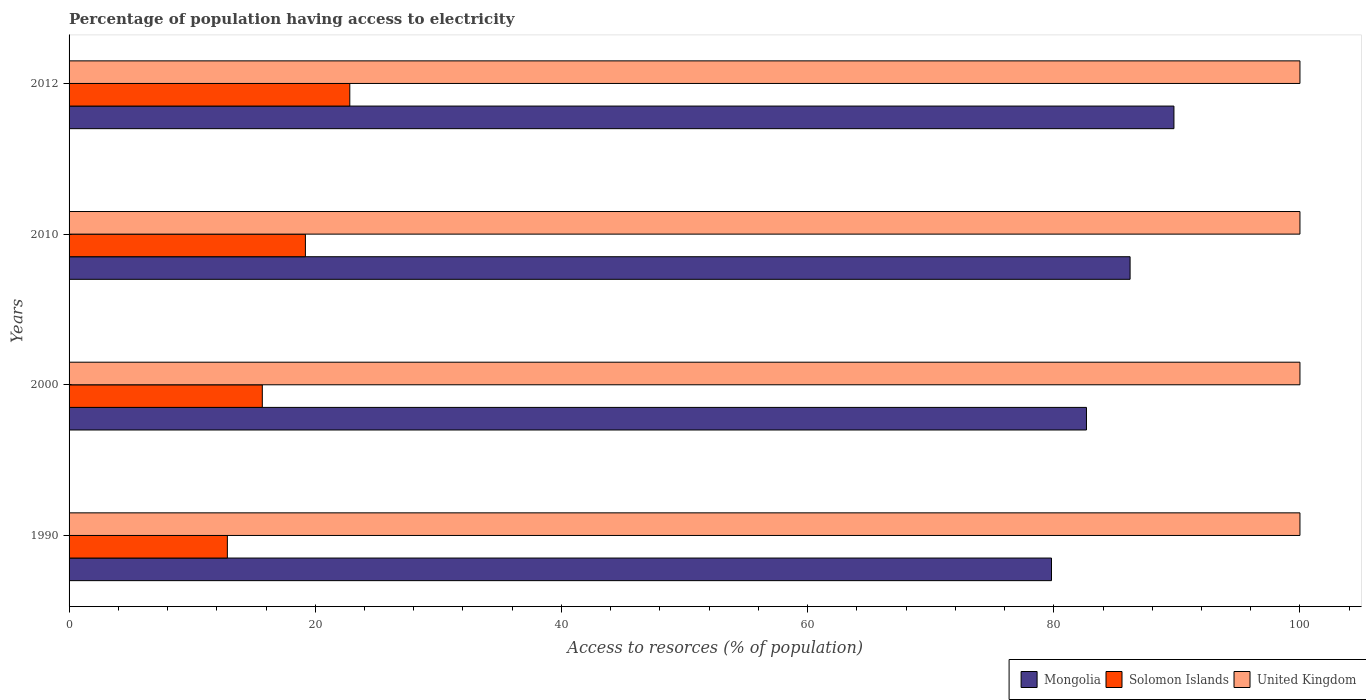How many different coloured bars are there?
Offer a terse response. 3. How many groups of bars are there?
Give a very brief answer. 4. Are the number of bars per tick equal to the number of legend labels?
Keep it short and to the point. Yes. Are the number of bars on each tick of the Y-axis equal?
Your answer should be very brief. Yes. How many bars are there on the 1st tick from the top?
Offer a terse response. 3. How many bars are there on the 1st tick from the bottom?
Give a very brief answer. 3. What is the percentage of population having access to electricity in Mongolia in 2010?
Your answer should be very brief. 86.2. Across all years, what is the maximum percentage of population having access to electricity in Solomon Islands?
Give a very brief answer. 22.81. Across all years, what is the minimum percentage of population having access to electricity in Mongolia?
Your answer should be very brief. 79.82. In which year was the percentage of population having access to electricity in Mongolia maximum?
Make the answer very short. 2012. In which year was the percentage of population having access to electricity in Mongolia minimum?
Your response must be concise. 1990. What is the total percentage of population having access to electricity in Solomon Islands in the graph?
Offer a terse response. 70.57. What is the difference between the percentage of population having access to electricity in Solomon Islands in 1990 and that in 2012?
Your response must be concise. -9.95. What is the difference between the percentage of population having access to electricity in Solomon Islands in 2000 and the percentage of population having access to electricity in Mongolia in 2012?
Your answer should be very brief. -74.06. What is the average percentage of population having access to electricity in Mongolia per year?
Your response must be concise. 84.61. In the year 2012, what is the difference between the percentage of population having access to electricity in Solomon Islands and percentage of population having access to electricity in Mongolia?
Make the answer very short. -66.96. What is the ratio of the percentage of population having access to electricity in United Kingdom in 1990 to that in 2012?
Offer a very short reply. 1. What is the difference between the highest and the lowest percentage of population having access to electricity in Solomon Islands?
Offer a terse response. 9.95. In how many years, is the percentage of population having access to electricity in Mongolia greater than the average percentage of population having access to electricity in Mongolia taken over all years?
Offer a terse response. 2. Is the sum of the percentage of population having access to electricity in Mongolia in 1990 and 2012 greater than the maximum percentage of population having access to electricity in United Kingdom across all years?
Your answer should be very brief. Yes. What does the 1st bar from the bottom in 1990 represents?
Offer a terse response. Mongolia. Is it the case that in every year, the sum of the percentage of population having access to electricity in Solomon Islands and percentage of population having access to electricity in United Kingdom is greater than the percentage of population having access to electricity in Mongolia?
Make the answer very short. Yes. How many bars are there?
Your answer should be compact. 12. How many years are there in the graph?
Provide a short and direct response. 4. Does the graph contain any zero values?
Offer a terse response. No. Does the graph contain grids?
Provide a succinct answer. No. Where does the legend appear in the graph?
Provide a short and direct response. Bottom right. How many legend labels are there?
Your answer should be compact. 3. How are the legend labels stacked?
Your response must be concise. Horizontal. What is the title of the graph?
Offer a terse response. Percentage of population having access to electricity. Does "Sao Tome and Principe" appear as one of the legend labels in the graph?
Your answer should be compact. No. What is the label or title of the X-axis?
Provide a succinct answer. Access to resorces (% of population). What is the Access to resorces (% of population) of Mongolia in 1990?
Give a very brief answer. 79.82. What is the Access to resorces (% of population) in Solomon Islands in 1990?
Provide a succinct answer. 12.86. What is the Access to resorces (% of population) in United Kingdom in 1990?
Your response must be concise. 100. What is the Access to resorces (% of population) of Mongolia in 2000?
Offer a terse response. 82.66. What is the Access to resorces (% of population) in Mongolia in 2010?
Give a very brief answer. 86.2. What is the Access to resorces (% of population) of Solomon Islands in 2010?
Make the answer very short. 19.2. What is the Access to resorces (% of population) of United Kingdom in 2010?
Offer a very short reply. 100. What is the Access to resorces (% of population) of Mongolia in 2012?
Your answer should be compact. 89.76. What is the Access to resorces (% of population) of Solomon Islands in 2012?
Provide a short and direct response. 22.81. What is the Access to resorces (% of population) in United Kingdom in 2012?
Keep it short and to the point. 100. Across all years, what is the maximum Access to resorces (% of population) of Mongolia?
Give a very brief answer. 89.76. Across all years, what is the maximum Access to resorces (% of population) in Solomon Islands?
Your answer should be compact. 22.81. Across all years, what is the minimum Access to resorces (% of population) of Mongolia?
Your response must be concise. 79.82. Across all years, what is the minimum Access to resorces (% of population) of Solomon Islands?
Keep it short and to the point. 12.86. Across all years, what is the minimum Access to resorces (% of population) in United Kingdom?
Provide a succinct answer. 100. What is the total Access to resorces (% of population) of Mongolia in the graph?
Your response must be concise. 338.43. What is the total Access to resorces (% of population) of Solomon Islands in the graph?
Provide a short and direct response. 70.57. What is the difference between the Access to resorces (% of population) of Mongolia in 1990 and that in 2000?
Offer a terse response. -2.84. What is the difference between the Access to resorces (% of population) of Solomon Islands in 1990 and that in 2000?
Your answer should be very brief. -2.84. What is the difference between the Access to resorces (% of population) of Mongolia in 1990 and that in 2010?
Offer a very short reply. -6.38. What is the difference between the Access to resorces (% of population) of Solomon Islands in 1990 and that in 2010?
Give a very brief answer. -6.34. What is the difference between the Access to resorces (% of population) in United Kingdom in 1990 and that in 2010?
Provide a short and direct response. 0. What is the difference between the Access to resorces (% of population) of Mongolia in 1990 and that in 2012?
Offer a terse response. -9.95. What is the difference between the Access to resorces (% of population) of Solomon Islands in 1990 and that in 2012?
Provide a short and direct response. -9.95. What is the difference between the Access to resorces (% of population) in United Kingdom in 1990 and that in 2012?
Keep it short and to the point. 0. What is the difference between the Access to resorces (% of population) in Mongolia in 2000 and that in 2010?
Your answer should be compact. -3.54. What is the difference between the Access to resorces (% of population) of Mongolia in 2000 and that in 2012?
Provide a succinct answer. -7.11. What is the difference between the Access to resorces (% of population) of Solomon Islands in 2000 and that in 2012?
Make the answer very short. -7.11. What is the difference between the Access to resorces (% of population) in Mongolia in 2010 and that in 2012?
Give a very brief answer. -3.56. What is the difference between the Access to resorces (% of population) in Solomon Islands in 2010 and that in 2012?
Offer a very short reply. -3.61. What is the difference between the Access to resorces (% of population) of United Kingdom in 2010 and that in 2012?
Your response must be concise. 0. What is the difference between the Access to resorces (% of population) in Mongolia in 1990 and the Access to resorces (% of population) in Solomon Islands in 2000?
Keep it short and to the point. 64.12. What is the difference between the Access to resorces (% of population) of Mongolia in 1990 and the Access to resorces (% of population) of United Kingdom in 2000?
Make the answer very short. -20.18. What is the difference between the Access to resorces (% of population) in Solomon Islands in 1990 and the Access to resorces (% of population) in United Kingdom in 2000?
Your answer should be very brief. -87.14. What is the difference between the Access to resorces (% of population) of Mongolia in 1990 and the Access to resorces (% of population) of Solomon Islands in 2010?
Make the answer very short. 60.62. What is the difference between the Access to resorces (% of population) of Mongolia in 1990 and the Access to resorces (% of population) of United Kingdom in 2010?
Give a very brief answer. -20.18. What is the difference between the Access to resorces (% of population) of Solomon Islands in 1990 and the Access to resorces (% of population) of United Kingdom in 2010?
Provide a succinct answer. -87.14. What is the difference between the Access to resorces (% of population) of Mongolia in 1990 and the Access to resorces (% of population) of Solomon Islands in 2012?
Your answer should be very brief. 57.01. What is the difference between the Access to resorces (% of population) in Mongolia in 1990 and the Access to resorces (% of population) in United Kingdom in 2012?
Provide a short and direct response. -20.18. What is the difference between the Access to resorces (% of population) of Solomon Islands in 1990 and the Access to resorces (% of population) of United Kingdom in 2012?
Keep it short and to the point. -87.14. What is the difference between the Access to resorces (% of population) in Mongolia in 2000 and the Access to resorces (% of population) in Solomon Islands in 2010?
Your answer should be very brief. 63.46. What is the difference between the Access to resorces (% of population) in Mongolia in 2000 and the Access to resorces (% of population) in United Kingdom in 2010?
Offer a terse response. -17.34. What is the difference between the Access to resorces (% of population) of Solomon Islands in 2000 and the Access to resorces (% of population) of United Kingdom in 2010?
Your answer should be compact. -84.3. What is the difference between the Access to resorces (% of population) of Mongolia in 2000 and the Access to resorces (% of population) of Solomon Islands in 2012?
Make the answer very short. 59.85. What is the difference between the Access to resorces (% of population) in Mongolia in 2000 and the Access to resorces (% of population) in United Kingdom in 2012?
Keep it short and to the point. -17.34. What is the difference between the Access to resorces (% of population) of Solomon Islands in 2000 and the Access to resorces (% of population) of United Kingdom in 2012?
Your response must be concise. -84.3. What is the difference between the Access to resorces (% of population) of Mongolia in 2010 and the Access to resorces (% of population) of Solomon Islands in 2012?
Your answer should be compact. 63.39. What is the difference between the Access to resorces (% of population) of Mongolia in 2010 and the Access to resorces (% of population) of United Kingdom in 2012?
Provide a succinct answer. -13.8. What is the difference between the Access to resorces (% of population) of Solomon Islands in 2010 and the Access to resorces (% of population) of United Kingdom in 2012?
Your response must be concise. -80.8. What is the average Access to resorces (% of population) of Mongolia per year?
Provide a short and direct response. 84.61. What is the average Access to resorces (% of population) in Solomon Islands per year?
Make the answer very short. 17.64. In the year 1990, what is the difference between the Access to resorces (% of population) in Mongolia and Access to resorces (% of population) in Solomon Islands?
Your response must be concise. 66.96. In the year 1990, what is the difference between the Access to resorces (% of population) in Mongolia and Access to resorces (% of population) in United Kingdom?
Make the answer very short. -20.18. In the year 1990, what is the difference between the Access to resorces (% of population) in Solomon Islands and Access to resorces (% of population) in United Kingdom?
Make the answer very short. -87.14. In the year 2000, what is the difference between the Access to resorces (% of population) of Mongolia and Access to resorces (% of population) of Solomon Islands?
Give a very brief answer. 66.96. In the year 2000, what is the difference between the Access to resorces (% of population) in Mongolia and Access to resorces (% of population) in United Kingdom?
Your answer should be very brief. -17.34. In the year 2000, what is the difference between the Access to resorces (% of population) of Solomon Islands and Access to resorces (% of population) of United Kingdom?
Your response must be concise. -84.3. In the year 2010, what is the difference between the Access to resorces (% of population) in Solomon Islands and Access to resorces (% of population) in United Kingdom?
Your response must be concise. -80.8. In the year 2012, what is the difference between the Access to resorces (% of population) of Mongolia and Access to resorces (% of population) of Solomon Islands?
Your answer should be very brief. 66.96. In the year 2012, what is the difference between the Access to resorces (% of population) in Mongolia and Access to resorces (% of population) in United Kingdom?
Make the answer very short. -10.24. In the year 2012, what is the difference between the Access to resorces (% of population) in Solomon Islands and Access to resorces (% of population) in United Kingdom?
Make the answer very short. -77.19. What is the ratio of the Access to resorces (% of population) of Mongolia in 1990 to that in 2000?
Provide a succinct answer. 0.97. What is the ratio of the Access to resorces (% of population) in Solomon Islands in 1990 to that in 2000?
Provide a short and direct response. 0.82. What is the ratio of the Access to resorces (% of population) of Mongolia in 1990 to that in 2010?
Your answer should be compact. 0.93. What is the ratio of the Access to resorces (% of population) in Solomon Islands in 1990 to that in 2010?
Offer a terse response. 0.67. What is the ratio of the Access to resorces (% of population) of Mongolia in 1990 to that in 2012?
Offer a very short reply. 0.89. What is the ratio of the Access to resorces (% of population) of Solomon Islands in 1990 to that in 2012?
Your answer should be compact. 0.56. What is the ratio of the Access to resorces (% of population) of United Kingdom in 1990 to that in 2012?
Offer a terse response. 1. What is the ratio of the Access to resorces (% of population) in Mongolia in 2000 to that in 2010?
Offer a terse response. 0.96. What is the ratio of the Access to resorces (% of population) of Solomon Islands in 2000 to that in 2010?
Your answer should be very brief. 0.82. What is the ratio of the Access to resorces (% of population) in Mongolia in 2000 to that in 2012?
Provide a short and direct response. 0.92. What is the ratio of the Access to resorces (% of population) of Solomon Islands in 2000 to that in 2012?
Offer a terse response. 0.69. What is the ratio of the Access to resorces (% of population) of United Kingdom in 2000 to that in 2012?
Make the answer very short. 1. What is the ratio of the Access to resorces (% of population) of Mongolia in 2010 to that in 2012?
Provide a succinct answer. 0.96. What is the ratio of the Access to resorces (% of population) of Solomon Islands in 2010 to that in 2012?
Your answer should be very brief. 0.84. What is the difference between the highest and the second highest Access to resorces (% of population) of Mongolia?
Your answer should be very brief. 3.56. What is the difference between the highest and the second highest Access to resorces (% of population) in Solomon Islands?
Make the answer very short. 3.61. What is the difference between the highest and the lowest Access to resorces (% of population) of Mongolia?
Offer a very short reply. 9.95. What is the difference between the highest and the lowest Access to resorces (% of population) of Solomon Islands?
Give a very brief answer. 9.95. What is the difference between the highest and the lowest Access to resorces (% of population) of United Kingdom?
Give a very brief answer. 0. 